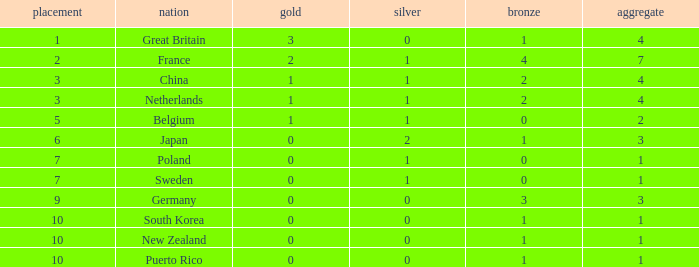What is the smallest number of gold where the total is less than 3 and the silver count is 2? None. 